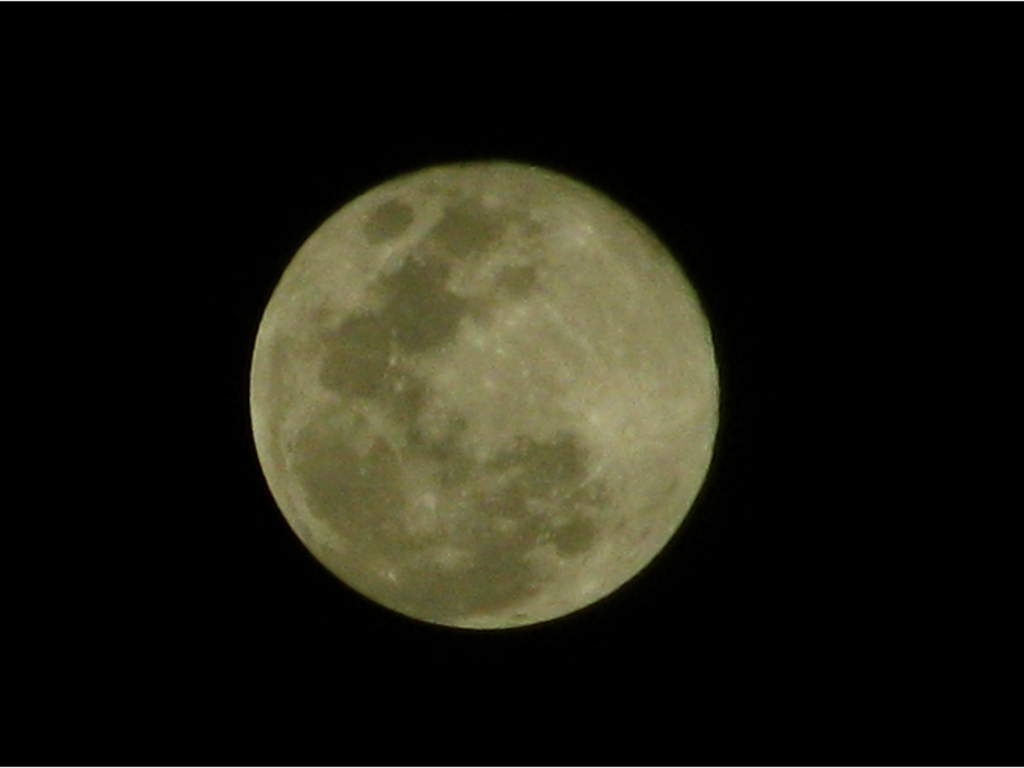What is the main subject of this image? The main subject of this image is the moon, captured in its full phase, where the entire face is illuminated by the sun's light. The detailed landscape of craters and plains known as 'maria' are visible, offering a glimpse into the moon's geologically active past. 